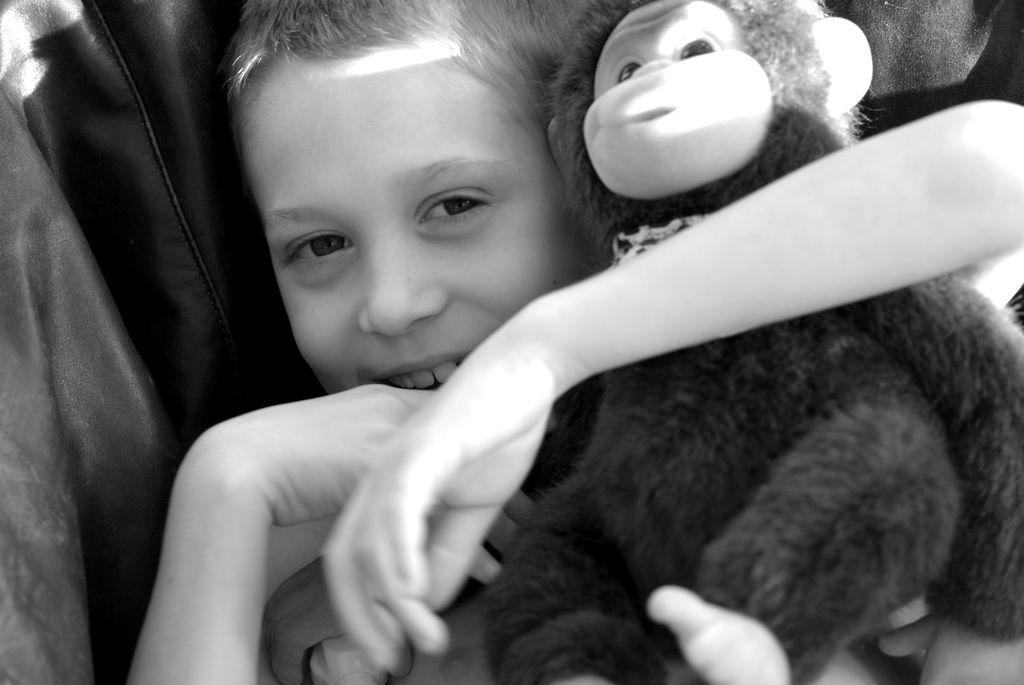Who is the main subject in the image? There is a boy in the image. What is the boy holding in his arms? The boy is holding a monkey toy in his arms. What type of owl can be seen sitting on the boy's shoulder in the image? There is no owl present in the image; the boy is holding a monkey toy. What tool is the boy using to fix the toy in the image? The boy is not using any tools in the image; he is simply holding the monkey toy. 